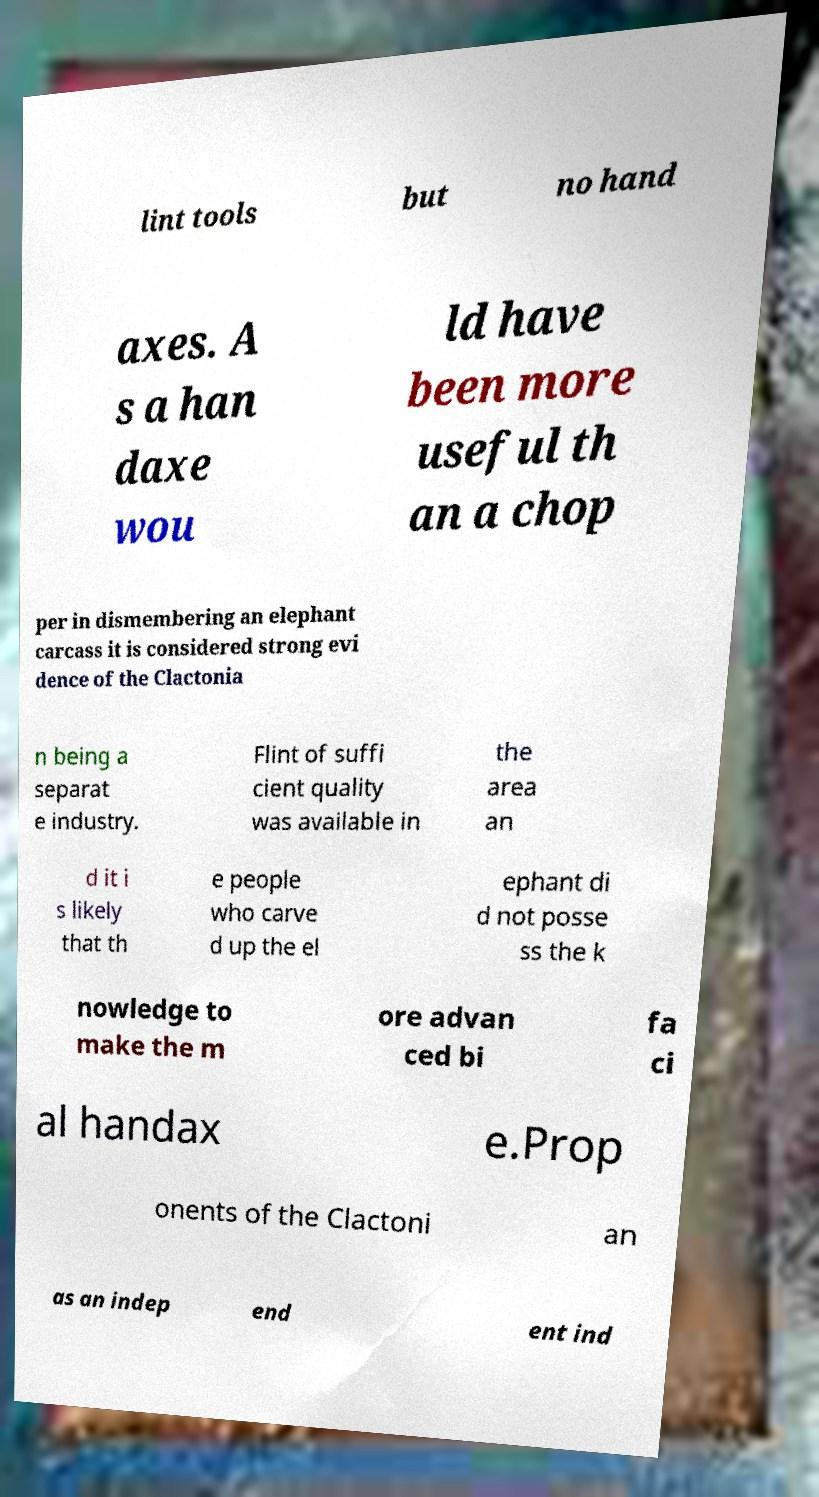Can you accurately transcribe the text from the provided image for me? lint tools but no hand axes. A s a han daxe wou ld have been more useful th an a chop per in dismembering an elephant carcass it is considered strong evi dence of the Clactonia n being a separat e industry. Flint of suffi cient quality was available in the area an d it i s likely that th e people who carve d up the el ephant di d not posse ss the k nowledge to make the m ore advan ced bi fa ci al handax e.Prop onents of the Clactoni an as an indep end ent ind 